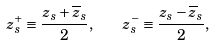<formula> <loc_0><loc_0><loc_500><loc_500>z ^ { + } _ { s } \equiv \frac { z _ { s } + \overline { z } _ { s } } { 2 } , \quad z ^ { - } _ { s } \equiv \frac { z _ { s } - \overline { z } _ { s } } { 2 } ,</formula> 